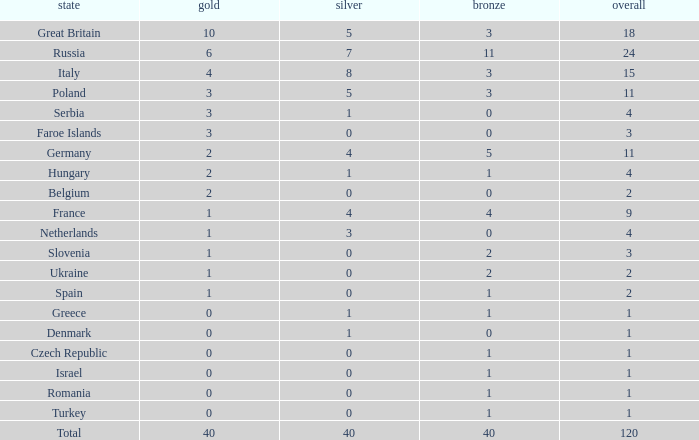What Nation has a Gold entry that is greater than 0, a Total that is greater than 2, a Silver entry that is larger than 1, and 0 Bronze? Netherlands. 